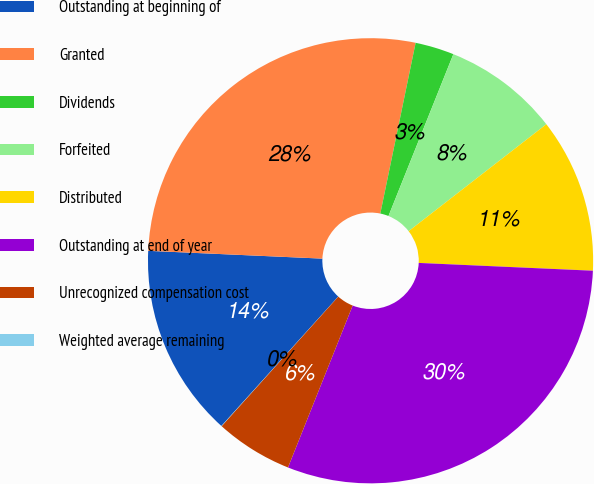<chart> <loc_0><loc_0><loc_500><loc_500><pie_chart><fcel>Outstanding at beginning of<fcel>Granted<fcel>Dividends<fcel>Forfeited<fcel>Distributed<fcel>Outstanding at end of year<fcel>Unrecognized compensation cost<fcel>Weighted average remaining<nl><fcel>14.02%<fcel>27.53%<fcel>2.82%<fcel>8.42%<fcel>11.22%<fcel>30.33%<fcel>5.62%<fcel>0.02%<nl></chart> 